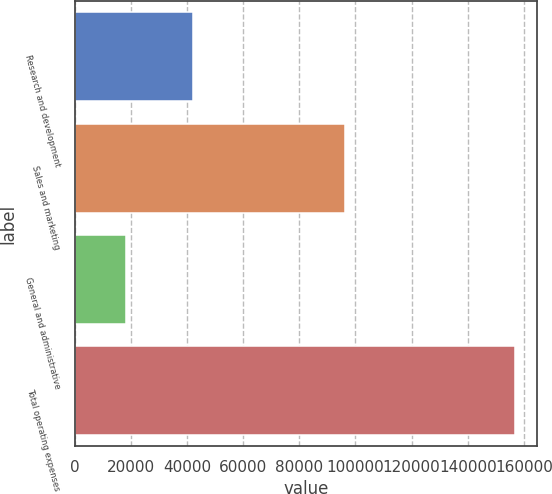Convert chart. <chart><loc_0><loc_0><loc_500><loc_500><bar_chart><fcel>Research and development<fcel>Sales and marketing<fcel>General and administrative<fcel>Total operating expenses<nl><fcel>42195<fcel>96291<fcel>18320<fcel>156806<nl></chart> 